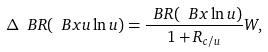<formula> <loc_0><loc_0><loc_500><loc_500>\Delta \ B R ( \ B x u \ln u ) = \frac { \ B R ( \ B x \ln u ) } { 1 + R _ { c / u } } W ,</formula> 